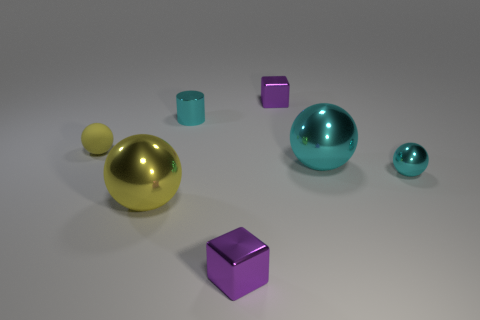What is the size of the other yellow object that is the same shape as the small yellow object?
Provide a short and direct response. Large. Is the large cyan thing made of the same material as the tiny cyan cylinder that is behind the tiny yellow thing?
Make the answer very short. Yes. How many objects are cyan objects or small cyan shiny things?
Keep it short and to the point. 3. Does the metal object behind the small metallic cylinder have the same size as the yellow ball to the right of the small matte object?
Your answer should be very brief. No. What number of cylinders are either tiny purple shiny objects or small cyan things?
Your answer should be very brief. 1. Are any tiny yellow things visible?
Keep it short and to the point. Yes. Are there any other things that are the same shape as the large yellow object?
Offer a very short reply. Yes. Is the tiny shiny ball the same color as the metallic cylinder?
Your answer should be very brief. Yes. How many things are either metallic objects left of the big cyan object or tiny yellow matte balls?
Keep it short and to the point. 5. What number of tiny purple metallic cubes are in front of the tiny metallic block behind the purple metal object that is in front of the rubber object?
Give a very brief answer. 1. 